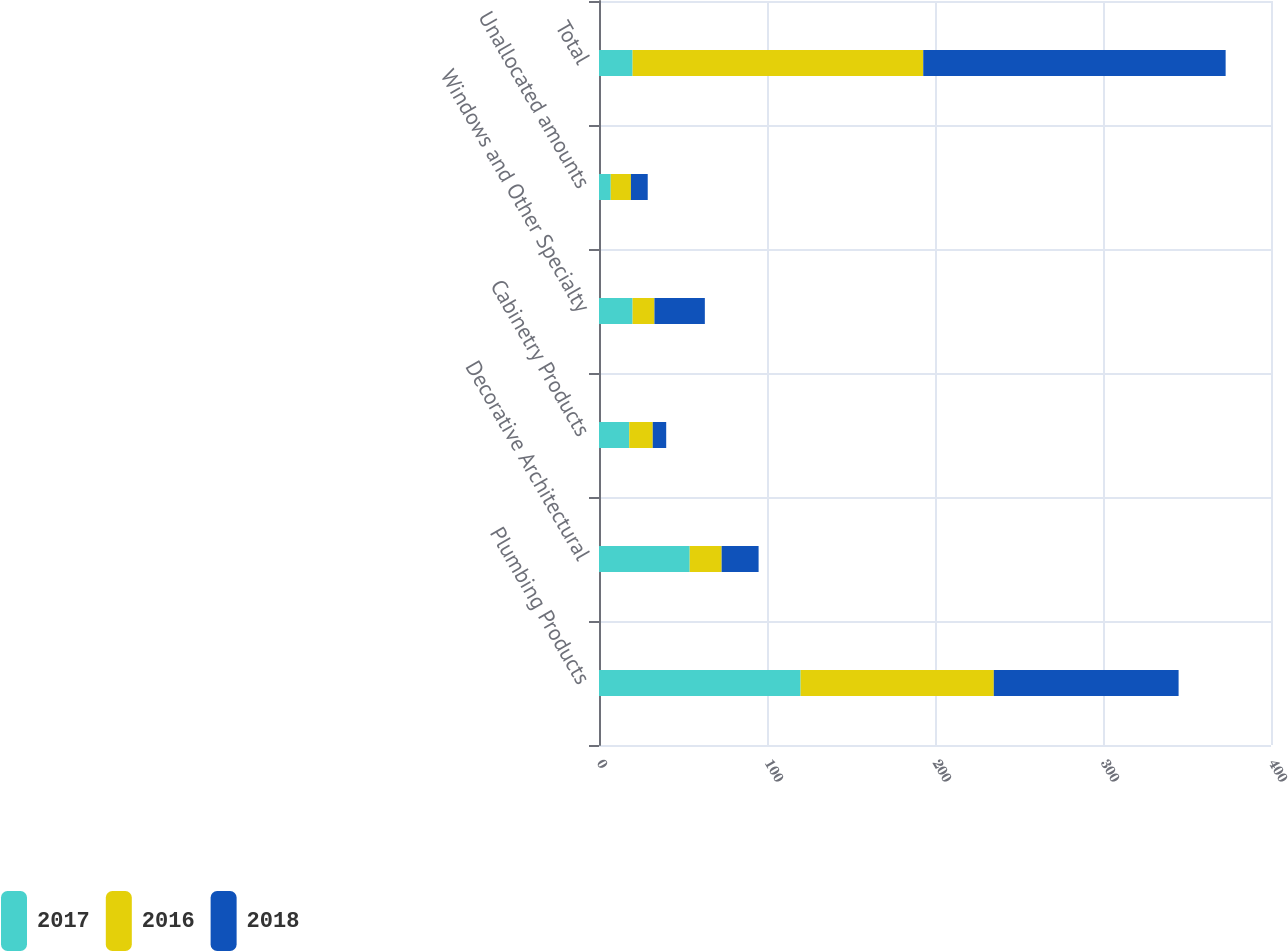Convert chart. <chart><loc_0><loc_0><loc_500><loc_500><stacked_bar_chart><ecel><fcel>Plumbing Products<fcel>Decorative Architectural<fcel>Cabinetry Products<fcel>Windows and Other Specialty<fcel>Unallocated amounts<fcel>Total<nl><fcel>2017<fcel>120<fcel>54<fcel>18<fcel>20<fcel>7<fcel>20<nl><fcel>2016<fcel>115<fcel>19<fcel>14<fcel>13<fcel>12<fcel>173<nl><fcel>2018<fcel>110<fcel>22<fcel>8<fcel>30<fcel>10<fcel>180<nl></chart> 